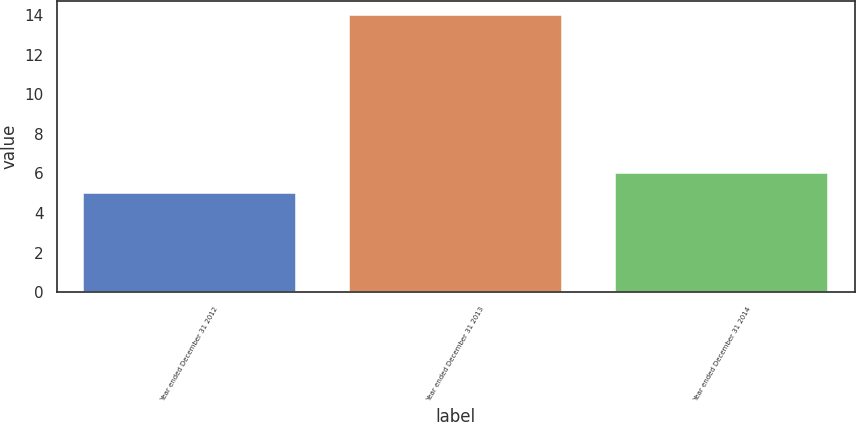Convert chart to OTSL. <chart><loc_0><loc_0><loc_500><loc_500><bar_chart><fcel>Year ended December 31 2012<fcel>Year ended December 31 2013<fcel>Year ended December 31 2014<nl><fcel>5<fcel>14<fcel>6<nl></chart> 